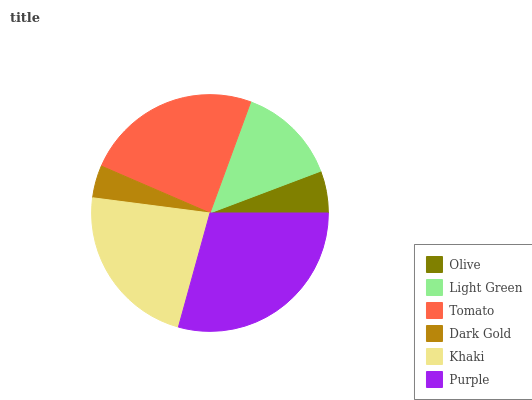Is Dark Gold the minimum?
Answer yes or no. Yes. Is Purple the maximum?
Answer yes or no. Yes. Is Light Green the minimum?
Answer yes or no. No. Is Light Green the maximum?
Answer yes or no. No. Is Light Green greater than Olive?
Answer yes or no. Yes. Is Olive less than Light Green?
Answer yes or no. Yes. Is Olive greater than Light Green?
Answer yes or no. No. Is Light Green less than Olive?
Answer yes or no. No. Is Khaki the high median?
Answer yes or no. Yes. Is Light Green the low median?
Answer yes or no. Yes. Is Olive the high median?
Answer yes or no. No. Is Dark Gold the low median?
Answer yes or no. No. 